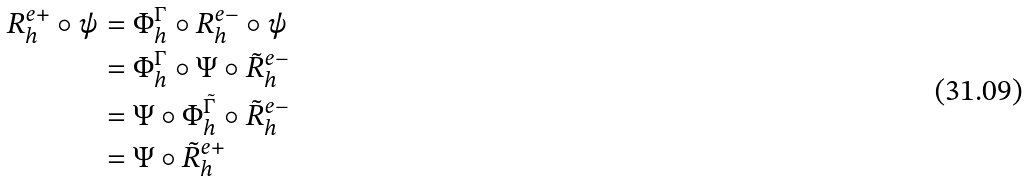<formula> <loc_0><loc_0><loc_500><loc_500>R ^ { e + } _ { h } \circ \psi & = \Phi ^ { \Gamma } _ { h } \circ R ^ { e - } _ { h } \circ \psi \\ & = \Phi ^ { \Gamma } _ { h } \circ \Psi \circ \tilde { R } ^ { e - } _ { h } \\ & = \Psi \circ \Phi ^ { \tilde { \Gamma } } _ { h } \circ \tilde { R } ^ { e - } _ { h } \\ & = \Psi \circ \tilde { R } ^ { e + } _ { h } \\</formula> 